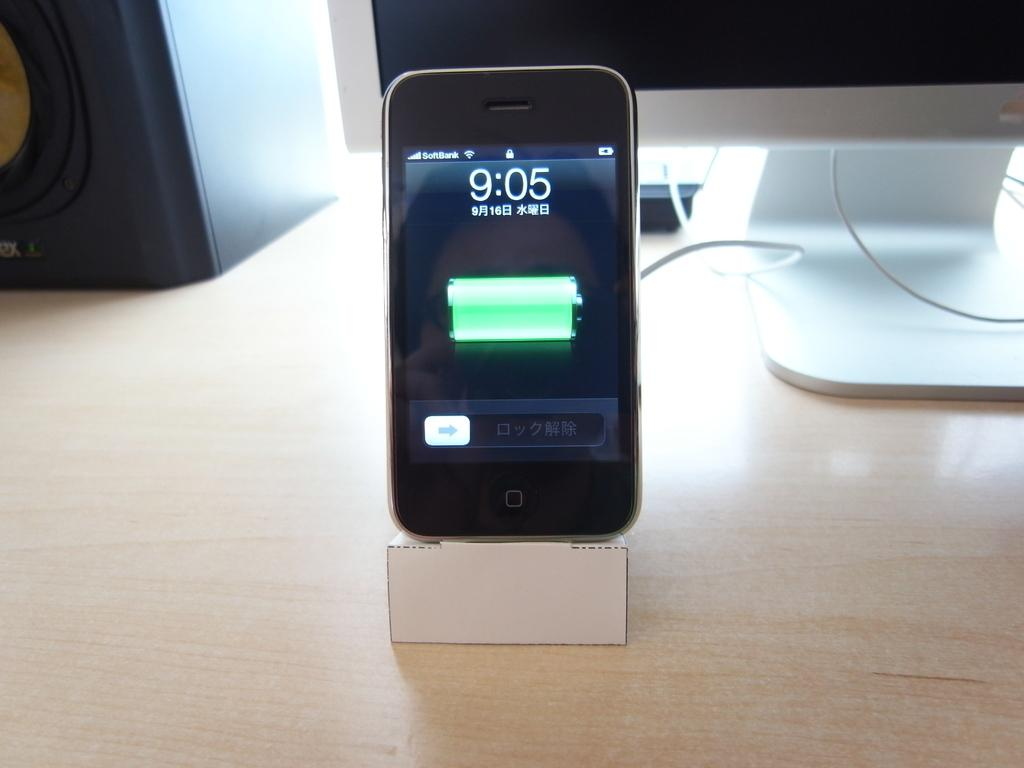<image>
Offer a succinct explanation of the picture presented. a phone that has the time of 9:05 on it 